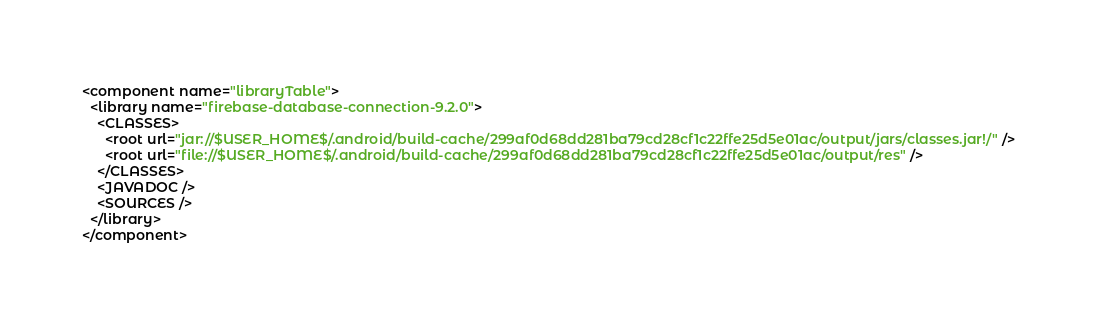<code> <loc_0><loc_0><loc_500><loc_500><_XML_><component name="libraryTable">
  <library name="firebase-database-connection-9.2.0">
    <CLASSES>
      <root url="jar://$USER_HOME$/.android/build-cache/299af0d68dd281ba79cd28cf1c22ffe25d5e01ac/output/jars/classes.jar!/" />
      <root url="file://$USER_HOME$/.android/build-cache/299af0d68dd281ba79cd28cf1c22ffe25d5e01ac/output/res" />
    </CLASSES>
    <JAVADOC />
    <SOURCES />
  </library>
</component></code> 